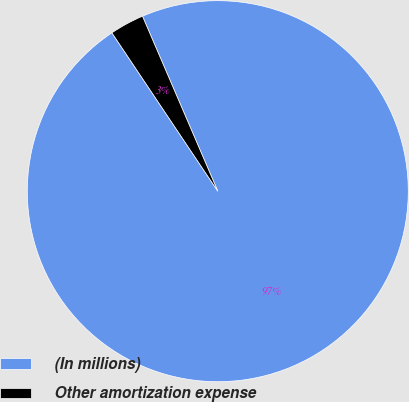<chart> <loc_0><loc_0><loc_500><loc_500><pie_chart><fcel>(In millions)<fcel>Other amortization expense<nl><fcel>97.09%<fcel>2.91%<nl></chart> 